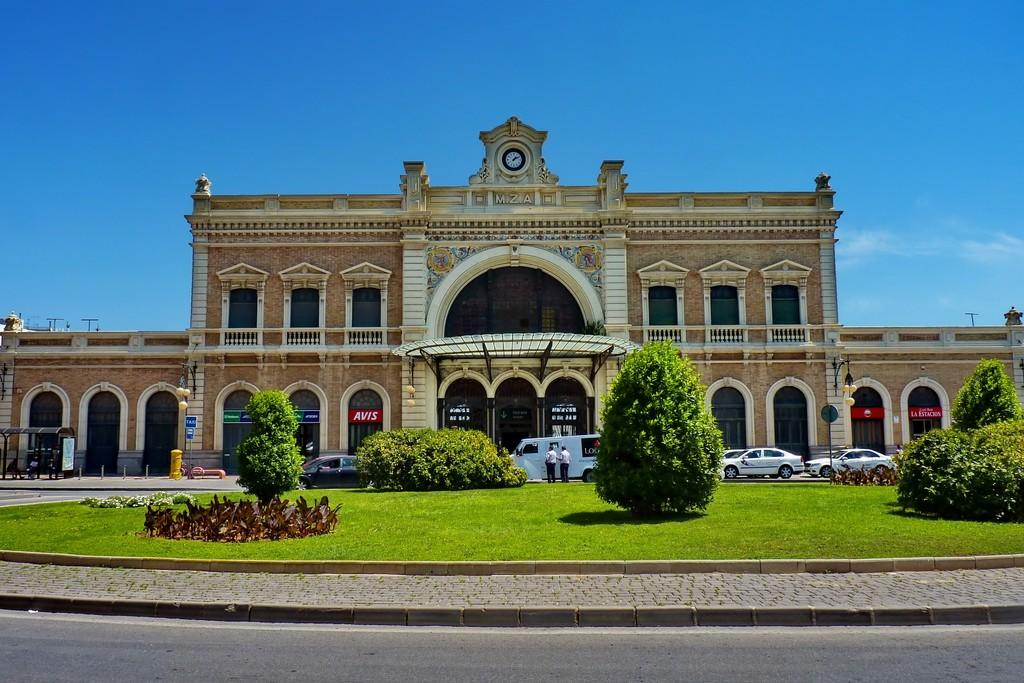<image>
Offer a succinct explanation of the picture presented. the outside of a large building with a red sign on a window that says 'avis' 